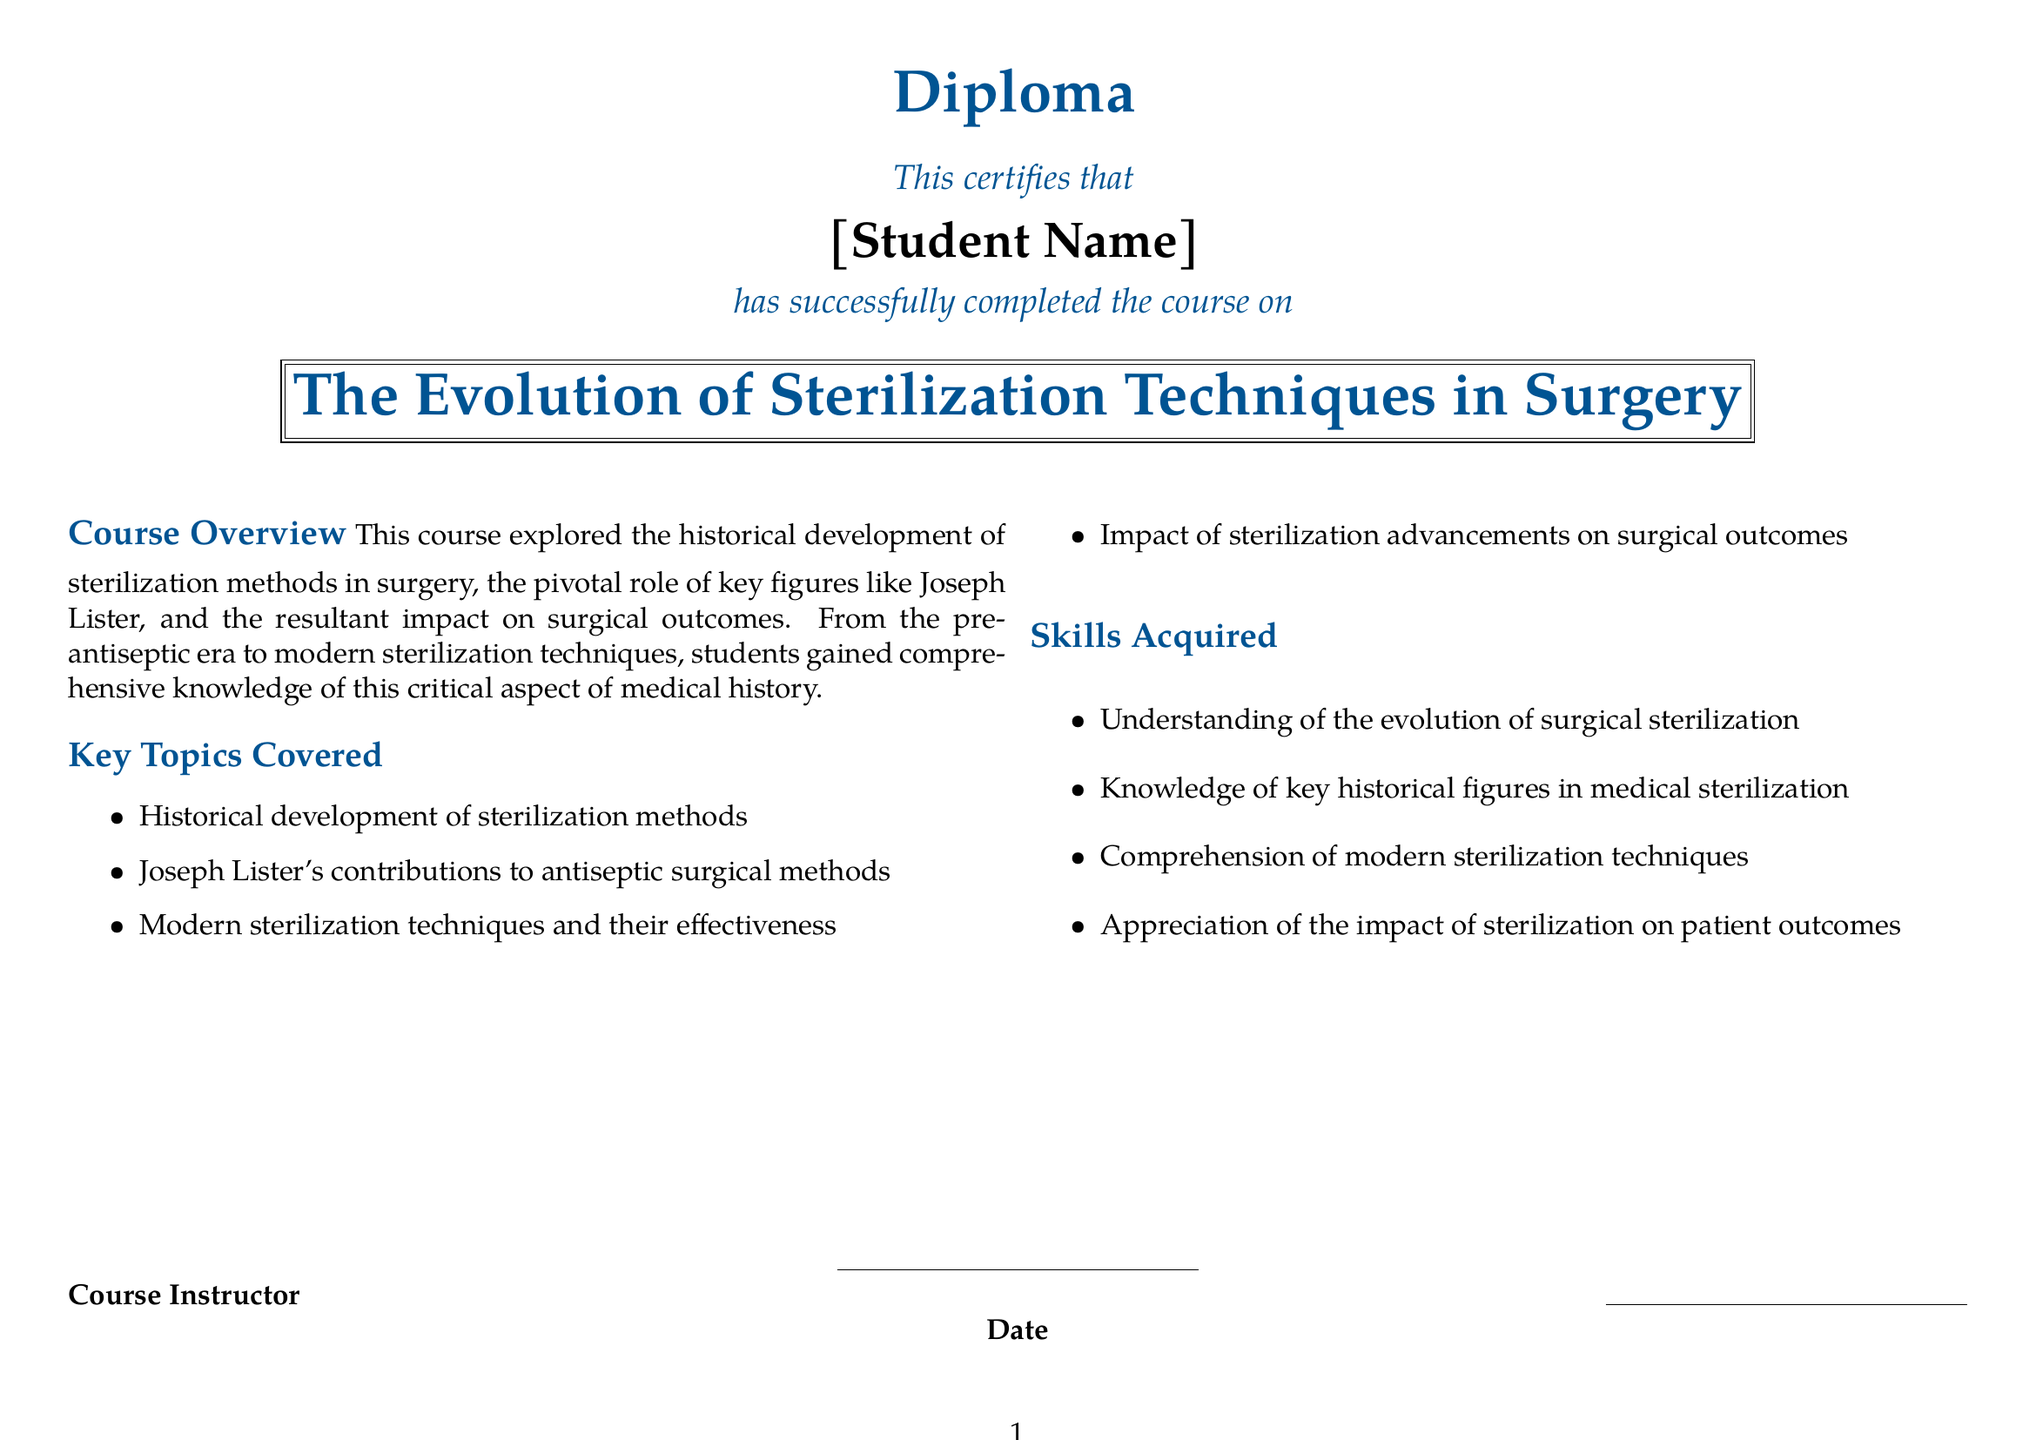what is the title of the course? The title of the course is stated in the diploma document as "The Evolution of Sterilization Techniques in Surgery."
Answer: The Evolution of Sterilization Techniques in Surgery who is a key figure in the history of sterilization methods? The document identifies Joseph Lister as a key figure in the history of sterilization methods.
Answer: Joseph Lister what skills are acquired from this course? The document outlines that understanding of the evolution of surgical sterilization is a skill acquired from the course.
Answer: Understanding of the evolution of surgical sterilization what aspect of medical history does the course focus on? The course focuses on the historical development of sterilization methods in surgery.
Answer: Historical development of sterilization methods in surgery what is one of the impacts of sterilization advancements mentioned? The impact of sterilization advancements on surgical outcomes is mentioned in the document.
Answer: Impact on surgical outcomes in which format is the diploma presented? The diploma is presented in a landscape format.
Answer: Landscape format who certifies the completion of the course? The course instructor certifies the completion of the course as indicated in the document.
Answer: Course Instructor what type of document is this? This document is a diploma.
Answer: Diploma 